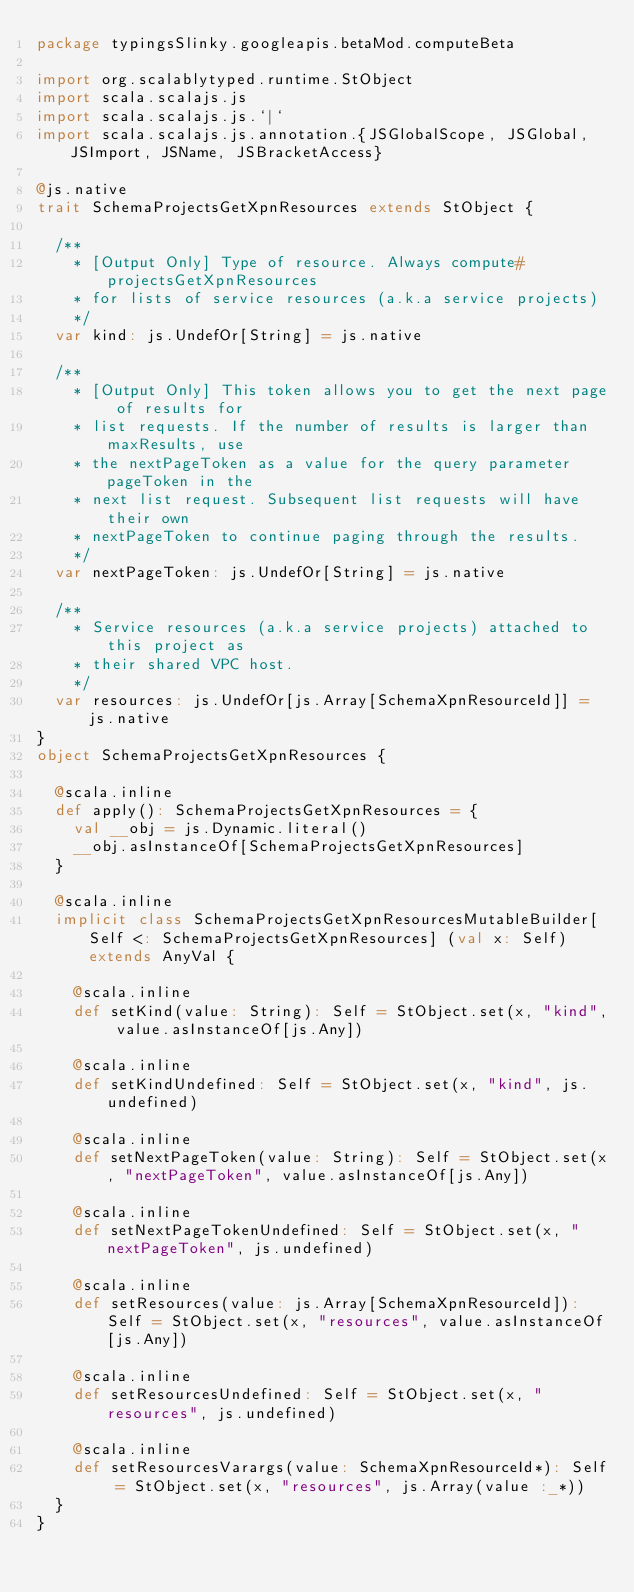Convert code to text. <code><loc_0><loc_0><loc_500><loc_500><_Scala_>package typingsSlinky.googleapis.betaMod.computeBeta

import org.scalablytyped.runtime.StObject
import scala.scalajs.js
import scala.scalajs.js.`|`
import scala.scalajs.js.annotation.{JSGlobalScope, JSGlobal, JSImport, JSName, JSBracketAccess}

@js.native
trait SchemaProjectsGetXpnResources extends StObject {
  
  /**
    * [Output Only] Type of resource. Always compute#projectsGetXpnResources
    * for lists of service resources (a.k.a service projects)
    */
  var kind: js.UndefOr[String] = js.native
  
  /**
    * [Output Only] This token allows you to get the next page of results for
    * list requests. If the number of results is larger than maxResults, use
    * the nextPageToken as a value for the query parameter pageToken in the
    * next list request. Subsequent list requests will have their own
    * nextPageToken to continue paging through the results.
    */
  var nextPageToken: js.UndefOr[String] = js.native
  
  /**
    * Service resources (a.k.a service projects) attached to this project as
    * their shared VPC host.
    */
  var resources: js.UndefOr[js.Array[SchemaXpnResourceId]] = js.native
}
object SchemaProjectsGetXpnResources {
  
  @scala.inline
  def apply(): SchemaProjectsGetXpnResources = {
    val __obj = js.Dynamic.literal()
    __obj.asInstanceOf[SchemaProjectsGetXpnResources]
  }
  
  @scala.inline
  implicit class SchemaProjectsGetXpnResourcesMutableBuilder[Self <: SchemaProjectsGetXpnResources] (val x: Self) extends AnyVal {
    
    @scala.inline
    def setKind(value: String): Self = StObject.set(x, "kind", value.asInstanceOf[js.Any])
    
    @scala.inline
    def setKindUndefined: Self = StObject.set(x, "kind", js.undefined)
    
    @scala.inline
    def setNextPageToken(value: String): Self = StObject.set(x, "nextPageToken", value.asInstanceOf[js.Any])
    
    @scala.inline
    def setNextPageTokenUndefined: Self = StObject.set(x, "nextPageToken", js.undefined)
    
    @scala.inline
    def setResources(value: js.Array[SchemaXpnResourceId]): Self = StObject.set(x, "resources", value.asInstanceOf[js.Any])
    
    @scala.inline
    def setResourcesUndefined: Self = StObject.set(x, "resources", js.undefined)
    
    @scala.inline
    def setResourcesVarargs(value: SchemaXpnResourceId*): Self = StObject.set(x, "resources", js.Array(value :_*))
  }
}
</code> 